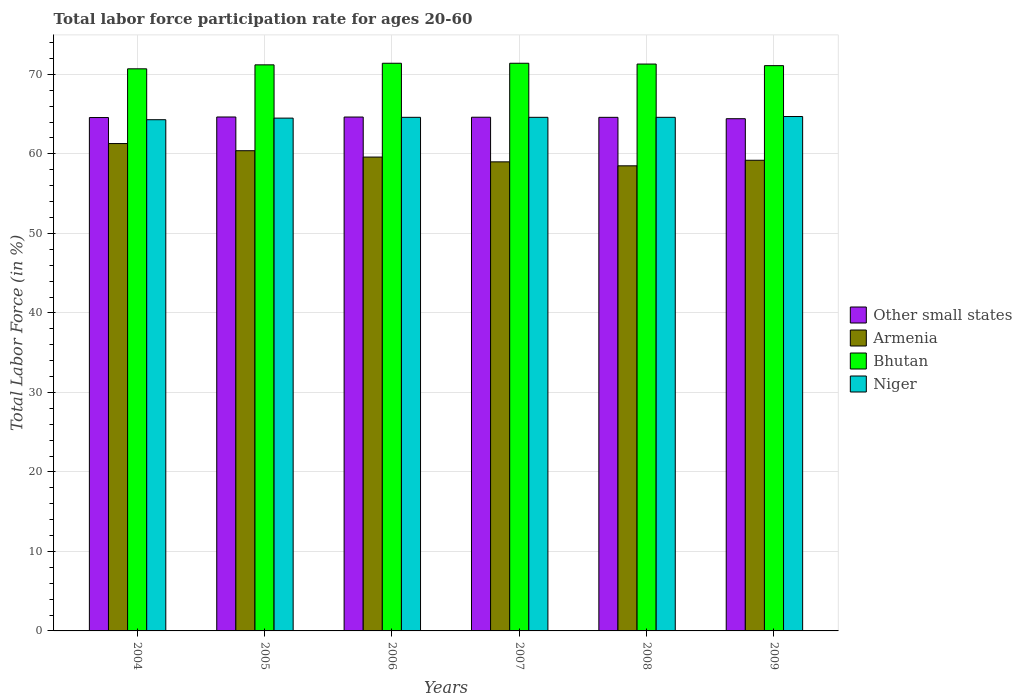How many groups of bars are there?
Make the answer very short. 6. Are the number of bars per tick equal to the number of legend labels?
Provide a succinct answer. Yes. How many bars are there on the 2nd tick from the left?
Offer a very short reply. 4. How many bars are there on the 4th tick from the right?
Offer a very short reply. 4. What is the labor force participation rate in Armenia in 2006?
Your answer should be compact. 59.6. Across all years, what is the maximum labor force participation rate in Niger?
Make the answer very short. 64.7. Across all years, what is the minimum labor force participation rate in Armenia?
Your response must be concise. 58.5. In which year was the labor force participation rate in Armenia maximum?
Offer a very short reply. 2004. In which year was the labor force participation rate in Bhutan minimum?
Ensure brevity in your answer.  2004. What is the total labor force participation rate in Niger in the graph?
Ensure brevity in your answer.  387.3. What is the difference between the labor force participation rate in Niger in 2004 and that in 2007?
Keep it short and to the point. -0.3. What is the difference between the labor force participation rate in Armenia in 2007 and the labor force participation rate in Other small states in 2006?
Your answer should be very brief. -5.64. What is the average labor force participation rate in Armenia per year?
Ensure brevity in your answer.  59.67. In the year 2005, what is the difference between the labor force participation rate in Armenia and labor force participation rate in Niger?
Offer a very short reply. -4.1. In how many years, is the labor force participation rate in Other small states greater than 68 %?
Offer a terse response. 0. What is the ratio of the labor force participation rate in Bhutan in 2004 to that in 2009?
Your response must be concise. 0.99. Is the labor force participation rate in Armenia in 2007 less than that in 2008?
Make the answer very short. No. What is the difference between the highest and the second highest labor force participation rate in Niger?
Provide a succinct answer. 0.1. What is the difference between the highest and the lowest labor force participation rate in Armenia?
Provide a succinct answer. 2.8. In how many years, is the labor force participation rate in Other small states greater than the average labor force participation rate in Other small states taken over all years?
Provide a short and direct response. 4. Is it the case that in every year, the sum of the labor force participation rate in Niger and labor force participation rate in Bhutan is greater than the sum of labor force participation rate in Armenia and labor force participation rate in Other small states?
Offer a very short reply. Yes. What does the 3rd bar from the left in 2009 represents?
Offer a very short reply. Bhutan. What does the 2nd bar from the right in 2007 represents?
Your response must be concise. Bhutan. How many bars are there?
Offer a terse response. 24. Are all the bars in the graph horizontal?
Provide a short and direct response. No. Are the values on the major ticks of Y-axis written in scientific E-notation?
Make the answer very short. No. Does the graph contain grids?
Make the answer very short. Yes. How many legend labels are there?
Provide a short and direct response. 4. What is the title of the graph?
Your response must be concise. Total labor force participation rate for ages 20-60. Does "Malawi" appear as one of the legend labels in the graph?
Make the answer very short. No. What is the label or title of the Y-axis?
Your answer should be compact. Total Labor Force (in %). What is the Total Labor Force (in %) of Other small states in 2004?
Provide a succinct answer. 64.57. What is the Total Labor Force (in %) in Armenia in 2004?
Make the answer very short. 61.3. What is the Total Labor Force (in %) of Bhutan in 2004?
Ensure brevity in your answer.  70.7. What is the Total Labor Force (in %) of Niger in 2004?
Your response must be concise. 64.3. What is the Total Labor Force (in %) in Other small states in 2005?
Offer a very short reply. 64.64. What is the Total Labor Force (in %) in Armenia in 2005?
Keep it short and to the point. 60.4. What is the Total Labor Force (in %) of Bhutan in 2005?
Make the answer very short. 71.2. What is the Total Labor Force (in %) in Niger in 2005?
Provide a succinct answer. 64.5. What is the Total Labor Force (in %) in Other small states in 2006?
Keep it short and to the point. 64.64. What is the Total Labor Force (in %) of Armenia in 2006?
Ensure brevity in your answer.  59.6. What is the Total Labor Force (in %) in Bhutan in 2006?
Your response must be concise. 71.4. What is the Total Labor Force (in %) of Niger in 2006?
Your answer should be very brief. 64.6. What is the Total Labor Force (in %) of Other small states in 2007?
Ensure brevity in your answer.  64.61. What is the Total Labor Force (in %) in Bhutan in 2007?
Offer a terse response. 71.4. What is the Total Labor Force (in %) of Niger in 2007?
Provide a short and direct response. 64.6. What is the Total Labor Force (in %) in Other small states in 2008?
Your answer should be compact. 64.6. What is the Total Labor Force (in %) of Armenia in 2008?
Offer a terse response. 58.5. What is the Total Labor Force (in %) of Bhutan in 2008?
Provide a succinct answer. 71.3. What is the Total Labor Force (in %) in Niger in 2008?
Make the answer very short. 64.6. What is the Total Labor Force (in %) of Other small states in 2009?
Your response must be concise. 64.42. What is the Total Labor Force (in %) in Armenia in 2009?
Make the answer very short. 59.2. What is the Total Labor Force (in %) in Bhutan in 2009?
Your answer should be very brief. 71.1. What is the Total Labor Force (in %) in Niger in 2009?
Your response must be concise. 64.7. Across all years, what is the maximum Total Labor Force (in %) of Other small states?
Offer a very short reply. 64.64. Across all years, what is the maximum Total Labor Force (in %) in Armenia?
Your answer should be very brief. 61.3. Across all years, what is the maximum Total Labor Force (in %) in Bhutan?
Provide a short and direct response. 71.4. Across all years, what is the maximum Total Labor Force (in %) of Niger?
Ensure brevity in your answer.  64.7. Across all years, what is the minimum Total Labor Force (in %) in Other small states?
Your answer should be very brief. 64.42. Across all years, what is the minimum Total Labor Force (in %) in Armenia?
Your answer should be compact. 58.5. Across all years, what is the minimum Total Labor Force (in %) in Bhutan?
Give a very brief answer. 70.7. Across all years, what is the minimum Total Labor Force (in %) of Niger?
Your response must be concise. 64.3. What is the total Total Labor Force (in %) of Other small states in the graph?
Provide a succinct answer. 387.48. What is the total Total Labor Force (in %) of Armenia in the graph?
Give a very brief answer. 358. What is the total Total Labor Force (in %) in Bhutan in the graph?
Offer a terse response. 427.1. What is the total Total Labor Force (in %) in Niger in the graph?
Your answer should be very brief. 387.3. What is the difference between the Total Labor Force (in %) in Other small states in 2004 and that in 2005?
Your answer should be compact. -0.07. What is the difference between the Total Labor Force (in %) of Armenia in 2004 and that in 2005?
Give a very brief answer. 0.9. What is the difference between the Total Labor Force (in %) in Bhutan in 2004 and that in 2005?
Your answer should be compact. -0.5. What is the difference between the Total Labor Force (in %) of Niger in 2004 and that in 2005?
Give a very brief answer. -0.2. What is the difference between the Total Labor Force (in %) of Other small states in 2004 and that in 2006?
Your answer should be compact. -0.06. What is the difference between the Total Labor Force (in %) in Armenia in 2004 and that in 2006?
Provide a short and direct response. 1.7. What is the difference between the Total Labor Force (in %) in Niger in 2004 and that in 2006?
Provide a succinct answer. -0.3. What is the difference between the Total Labor Force (in %) in Other small states in 2004 and that in 2007?
Provide a short and direct response. -0.04. What is the difference between the Total Labor Force (in %) in Armenia in 2004 and that in 2007?
Offer a terse response. 2.3. What is the difference between the Total Labor Force (in %) in Bhutan in 2004 and that in 2007?
Your response must be concise. -0.7. What is the difference between the Total Labor Force (in %) of Niger in 2004 and that in 2007?
Make the answer very short. -0.3. What is the difference between the Total Labor Force (in %) of Other small states in 2004 and that in 2008?
Give a very brief answer. -0.02. What is the difference between the Total Labor Force (in %) in Armenia in 2004 and that in 2008?
Your answer should be compact. 2.8. What is the difference between the Total Labor Force (in %) in Bhutan in 2004 and that in 2008?
Give a very brief answer. -0.6. What is the difference between the Total Labor Force (in %) in Other small states in 2004 and that in 2009?
Your response must be concise. 0.15. What is the difference between the Total Labor Force (in %) in Other small states in 2005 and that in 2006?
Provide a succinct answer. 0.01. What is the difference between the Total Labor Force (in %) in Armenia in 2005 and that in 2006?
Offer a very short reply. 0.8. What is the difference between the Total Labor Force (in %) of Bhutan in 2005 and that in 2006?
Make the answer very short. -0.2. What is the difference between the Total Labor Force (in %) of Niger in 2005 and that in 2006?
Offer a terse response. -0.1. What is the difference between the Total Labor Force (in %) of Other small states in 2005 and that in 2007?
Keep it short and to the point. 0.03. What is the difference between the Total Labor Force (in %) of Armenia in 2005 and that in 2007?
Provide a short and direct response. 1.4. What is the difference between the Total Labor Force (in %) in Bhutan in 2005 and that in 2007?
Your response must be concise. -0.2. What is the difference between the Total Labor Force (in %) of Other small states in 2005 and that in 2008?
Give a very brief answer. 0.04. What is the difference between the Total Labor Force (in %) of Armenia in 2005 and that in 2008?
Provide a short and direct response. 1.9. What is the difference between the Total Labor Force (in %) of Other small states in 2005 and that in 2009?
Offer a very short reply. 0.22. What is the difference between the Total Labor Force (in %) of Armenia in 2005 and that in 2009?
Make the answer very short. 1.2. What is the difference between the Total Labor Force (in %) of Other small states in 2006 and that in 2007?
Your response must be concise. 0.02. What is the difference between the Total Labor Force (in %) in Armenia in 2006 and that in 2007?
Your answer should be compact. 0.6. What is the difference between the Total Labor Force (in %) in Bhutan in 2006 and that in 2007?
Make the answer very short. 0. What is the difference between the Total Labor Force (in %) of Other small states in 2006 and that in 2008?
Provide a succinct answer. 0.04. What is the difference between the Total Labor Force (in %) of Armenia in 2006 and that in 2008?
Provide a succinct answer. 1.1. What is the difference between the Total Labor Force (in %) of Niger in 2006 and that in 2008?
Offer a very short reply. 0. What is the difference between the Total Labor Force (in %) in Other small states in 2006 and that in 2009?
Make the answer very short. 0.21. What is the difference between the Total Labor Force (in %) in Bhutan in 2006 and that in 2009?
Provide a succinct answer. 0.3. What is the difference between the Total Labor Force (in %) in Other small states in 2007 and that in 2008?
Provide a short and direct response. 0.01. What is the difference between the Total Labor Force (in %) in Armenia in 2007 and that in 2008?
Your answer should be compact. 0.5. What is the difference between the Total Labor Force (in %) in Other small states in 2007 and that in 2009?
Provide a short and direct response. 0.19. What is the difference between the Total Labor Force (in %) of Bhutan in 2007 and that in 2009?
Provide a succinct answer. 0.3. What is the difference between the Total Labor Force (in %) of Niger in 2007 and that in 2009?
Ensure brevity in your answer.  -0.1. What is the difference between the Total Labor Force (in %) in Other small states in 2008 and that in 2009?
Provide a succinct answer. 0.17. What is the difference between the Total Labor Force (in %) in Bhutan in 2008 and that in 2009?
Offer a terse response. 0.2. What is the difference between the Total Labor Force (in %) in Niger in 2008 and that in 2009?
Your answer should be very brief. -0.1. What is the difference between the Total Labor Force (in %) of Other small states in 2004 and the Total Labor Force (in %) of Armenia in 2005?
Give a very brief answer. 4.17. What is the difference between the Total Labor Force (in %) in Other small states in 2004 and the Total Labor Force (in %) in Bhutan in 2005?
Offer a very short reply. -6.63. What is the difference between the Total Labor Force (in %) in Other small states in 2004 and the Total Labor Force (in %) in Niger in 2005?
Your response must be concise. 0.07. What is the difference between the Total Labor Force (in %) of Armenia in 2004 and the Total Labor Force (in %) of Bhutan in 2005?
Provide a short and direct response. -9.9. What is the difference between the Total Labor Force (in %) of Armenia in 2004 and the Total Labor Force (in %) of Niger in 2005?
Your answer should be very brief. -3.2. What is the difference between the Total Labor Force (in %) in Bhutan in 2004 and the Total Labor Force (in %) in Niger in 2005?
Ensure brevity in your answer.  6.2. What is the difference between the Total Labor Force (in %) of Other small states in 2004 and the Total Labor Force (in %) of Armenia in 2006?
Provide a succinct answer. 4.97. What is the difference between the Total Labor Force (in %) in Other small states in 2004 and the Total Labor Force (in %) in Bhutan in 2006?
Your response must be concise. -6.83. What is the difference between the Total Labor Force (in %) in Other small states in 2004 and the Total Labor Force (in %) in Niger in 2006?
Your answer should be very brief. -0.03. What is the difference between the Total Labor Force (in %) in Armenia in 2004 and the Total Labor Force (in %) in Bhutan in 2006?
Offer a very short reply. -10.1. What is the difference between the Total Labor Force (in %) of Bhutan in 2004 and the Total Labor Force (in %) of Niger in 2006?
Keep it short and to the point. 6.1. What is the difference between the Total Labor Force (in %) in Other small states in 2004 and the Total Labor Force (in %) in Armenia in 2007?
Offer a terse response. 5.57. What is the difference between the Total Labor Force (in %) in Other small states in 2004 and the Total Labor Force (in %) in Bhutan in 2007?
Offer a very short reply. -6.83. What is the difference between the Total Labor Force (in %) of Other small states in 2004 and the Total Labor Force (in %) of Niger in 2007?
Provide a short and direct response. -0.03. What is the difference between the Total Labor Force (in %) of Armenia in 2004 and the Total Labor Force (in %) of Bhutan in 2007?
Offer a very short reply. -10.1. What is the difference between the Total Labor Force (in %) of Bhutan in 2004 and the Total Labor Force (in %) of Niger in 2007?
Your response must be concise. 6.1. What is the difference between the Total Labor Force (in %) of Other small states in 2004 and the Total Labor Force (in %) of Armenia in 2008?
Your answer should be compact. 6.07. What is the difference between the Total Labor Force (in %) of Other small states in 2004 and the Total Labor Force (in %) of Bhutan in 2008?
Offer a terse response. -6.73. What is the difference between the Total Labor Force (in %) in Other small states in 2004 and the Total Labor Force (in %) in Niger in 2008?
Offer a very short reply. -0.03. What is the difference between the Total Labor Force (in %) in Armenia in 2004 and the Total Labor Force (in %) in Bhutan in 2008?
Your answer should be compact. -10. What is the difference between the Total Labor Force (in %) of Armenia in 2004 and the Total Labor Force (in %) of Niger in 2008?
Give a very brief answer. -3.3. What is the difference between the Total Labor Force (in %) in Bhutan in 2004 and the Total Labor Force (in %) in Niger in 2008?
Give a very brief answer. 6.1. What is the difference between the Total Labor Force (in %) in Other small states in 2004 and the Total Labor Force (in %) in Armenia in 2009?
Give a very brief answer. 5.37. What is the difference between the Total Labor Force (in %) of Other small states in 2004 and the Total Labor Force (in %) of Bhutan in 2009?
Your answer should be compact. -6.53. What is the difference between the Total Labor Force (in %) of Other small states in 2004 and the Total Labor Force (in %) of Niger in 2009?
Your answer should be compact. -0.13. What is the difference between the Total Labor Force (in %) in Armenia in 2004 and the Total Labor Force (in %) in Bhutan in 2009?
Provide a succinct answer. -9.8. What is the difference between the Total Labor Force (in %) in Bhutan in 2004 and the Total Labor Force (in %) in Niger in 2009?
Ensure brevity in your answer.  6. What is the difference between the Total Labor Force (in %) of Other small states in 2005 and the Total Labor Force (in %) of Armenia in 2006?
Keep it short and to the point. 5.04. What is the difference between the Total Labor Force (in %) in Other small states in 2005 and the Total Labor Force (in %) in Bhutan in 2006?
Give a very brief answer. -6.76. What is the difference between the Total Labor Force (in %) of Other small states in 2005 and the Total Labor Force (in %) of Niger in 2006?
Your answer should be compact. 0.04. What is the difference between the Total Labor Force (in %) of Bhutan in 2005 and the Total Labor Force (in %) of Niger in 2006?
Offer a very short reply. 6.6. What is the difference between the Total Labor Force (in %) in Other small states in 2005 and the Total Labor Force (in %) in Armenia in 2007?
Your answer should be compact. 5.64. What is the difference between the Total Labor Force (in %) in Other small states in 2005 and the Total Labor Force (in %) in Bhutan in 2007?
Provide a succinct answer. -6.76. What is the difference between the Total Labor Force (in %) of Other small states in 2005 and the Total Labor Force (in %) of Niger in 2007?
Offer a terse response. 0.04. What is the difference between the Total Labor Force (in %) in Armenia in 2005 and the Total Labor Force (in %) in Bhutan in 2007?
Offer a terse response. -11. What is the difference between the Total Labor Force (in %) in Armenia in 2005 and the Total Labor Force (in %) in Niger in 2007?
Your answer should be very brief. -4.2. What is the difference between the Total Labor Force (in %) in Other small states in 2005 and the Total Labor Force (in %) in Armenia in 2008?
Offer a very short reply. 6.14. What is the difference between the Total Labor Force (in %) in Other small states in 2005 and the Total Labor Force (in %) in Bhutan in 2008?
Make the answer very short. -6.66. What is the difference between the Total Labor Force (in %) of Other small states in 2005 and the Total Labor Force (in %) of Niger in 2008?
Keep it short and to the point. 0.04. What is the difference between the Total Labor Force (in %) of Bhutan in 2005 and the Total Labor Force (in %) of Niger in 2008?
Ensure brevity in your answer.  6.6. What is the difference between the Total Labor Force (in %) in Other small states in 2005 and the Total Labor Force (in %) in Armenia in 2009?
Offer a terse response. 5.44. What is the difference between the Total Labor Force (in %) of Other small states in 2005 and the Total Labor Force (in %) of Bhutan in 2009?
Your response must be concise. -6.46. What is the difference between the Total Labor Force (in %) of Other small states in 2005 and the Total Labor Force (in %) of Niger in 2009?
Provide a succinct answer. -0.06. What is the difference between the Total Labor Force (in %) in Armenia in 2005 and the Total Labor Force (in %) in Niger in 2009?
Offer a terse response. -4.3. What is the difference between the Total Labor Force (in %) in Bhutan in 2005 and the Total Labor Force (in %) in Niger in 2009?
Provide a succinct answer. 6.5. What is the difference between the Total Labor Force (in %) in Other small states in 2006 and the Total Labor Force (in %) in Armenia in 2007?
Keep it short and to the point. 5.64. What is the difference between the Total Labor Force (in %) of Other small states in 2006 and the Total Labor Force (in %) of Bhutan in 2007?
Your answer should be very brief. -6.76. What is the difference between the Total Labor Force (in %) in Other small states in 2006 and the Total Labor Force (in %) in Niger in 2007?
Provide a succinct answer. 0.04. What is the difference between the Total Labor Force (in %) in Armenia in 2006 and the Total Labor Force (in %) in Bhutan in 2007?
Offer a very short reply. -11.8. What is the difference between the Total Labor Force (in %) in Armenia in 2006 and the Total Labor Force (in %) in Niger in 2007?
Offer a terse response. -5. What is the difference between the Total Labor Force (in %) of Other small states in 2006 and the Total Labor Force (in %) of Armenia in 2008?
Provide a succinct answer. 6.14. What is the difference between the Total Labor Force (in %) of Other small states in 2006 and the Total Labor Force (in %) of Bhutan in 2008?
Ensure brevity in your answer.  -6.66. What is the difference between the Total Labor Force (in %) in Other small states in 2006 and the Total Labor Force (in %) in Niger in 2008?
Your response must be concise. 0.04. What is the difference between the Total Labor Force (in %) of Armenia in 2006 and the Total Labor Force (in %) of Bhutan in 2008?
Your response must be concise. -11.7. What is the difference between the Total Labor Force (in %) in Armenia in 2006 and the Total Labor Force (in %) in Niger in 2008?
Provide a succinct answer. -5. What is the difference between the Total Labor Force (in %) in Other small states in 2006 and the Total Labor Force (in %) in Armenia in 2009?
Offer a terse response. 5.44. What is the difference between the Total Labor Force (in %) in Other small states in 2006 and the Total Labor Force (in %) in Bhutan in 2009?
Your response must be concise. -6.46. What is the difference between the Total Labor Force (in %) of Other small states in 2006 and the Total Labor Force (in %) of Niger in 2009?
Offer a terse response. -0.06. What is the difference between the Total Labor Force (in %) in Armenia in 2006 and the Total Labor Force (in %) in Bhutan in 2009?
Your response must be concise. -11.5. What is the difference between the Total Labor Force (in %) of Armenia in 2006 and the Total Labor Force (in %) of Niger in 2009?
Offer a terse response. -5.1. What is the difference between the Total Labor Force (in %) of Bhutan in 2006 and the Total Labor Force (in %) of Niger in 2009?
Make the answer very short. 6.7. What is the difference between the Total Labor Force (in %) of Other small states in 2007 and the Total Labor Force (in %) of Armenia in 2008?
Ensure brevity in your answer.  6.11. What is the difference between the Total Labor Force (in %) in Other small states in 2007 and the Total Labor Force (in %) in Bhutan in 2008?
Make the answer very short. -6.69. What is the difference between the Total Labor Force (in %) in Other small states in 2007 and the Total Labor Force (in %) in Niger in 2008?
Provide a short and direct response. 0.01. What is the difference between the Total Labor Force (in %) in Armenia in 2007 and the Total Labor Force (in %) in Bhutan in 2008?
Provide a succinct answer. -12.3. What is the difference between the Total Labor Force (in %) in Other small states in 2007 and the Total Labor Force (in %) in Armenia in 2009?
Your response must be concise. 5.41. What is the difference between the Total Labor Force (in %) in Other small states in 2007 and the Total Labor Force (in %) in Bhutan in 2009?
Provide a succinct answer. -6.49. What is the difference between the Total Labor Force (in %) of Other small states in 2007 and the Total Labor Force (in %) of Niger in 2009?
Your answer should be compact. -0.09. What is the difference between the Total Labor Force (in %) of Armenia in 2007 and the Total Labor Force (in %) of Niger in 2009?
Your response must be concise. -5.7. What is the difference between the Total Labor Force (in %) of Other small states in 2008 and the Total Labor Force (in %) of Armenia in 2009?
Your answer should be very brief. 5.4. What is the difference between the Total Labor Force (in %) of Other small states in 2008 and the Total Labor Force (in %) of Bhutan in 2009?
Offer a very short reply. -6.5. What is the difference between the Total Labor Force (in %) in Other small states in 2008 and the Total Labor Force (in %) in Niger in 2009?
Keep it short and to the point. -0.1. What is the difference between the Total Labor Force (in %) of Armenia in 2008 and the Total Labor Force (in %) of Bhutan in 2009?
Your answer should be very brief. -12.6. What is the difference between the Total Labor Force (in %) in Armenia in 2008 and the Total Labor Force (in %) in Niger in 2009?
Offer a terse response. -6.2. What is the average Total Labor Force (in %) of Other small states per year?
Give a very brief answer. 64.58. What is the average Total Labor Force (in %) of Armenia per year?
Ensure brevity in your answer.  59.67. What is the average Total Labor Force (in %) of Bhutan per year?
Make the answer very short. 71.18. What is the average Total Labor Force (in %) of Niger per year?
Make the answer very short. 64.55. In the year 2004, what is the difference between the Total Labor Force (in %) in Other small states and Total Labor Force (in %) in Armenia?
Give a very brief answer. 3.27. In the year 2004, what is the difference between the Total Labor Force (in %) in Other small states and Total Labor Force (in %) in Bhutan?
Make the answer very short. -6.13. In the year 2004, what is the difference between the Total Labor Force (in %) in Other small states and Total Labor Force (in %) in Niger?
Provide a succinct answer. 0.27. In the year 2004, what is the difference between the Total Labor Force (in %) of Armenia and Total Labor Force (in %) of Bhutan?
Your answer should be compact. -9.4. In the year 2004, what is the difference between the Total Labor Force (in %) of Armenia and Total Labor Force (in %) of Niger?
Keep it short and to the point. -3. In the year 2005, what is the difference between the Total Labor Force (in %) in Other small states and Total Labor Force (in %) in Armenia?
Provide a short and direct response. 4.24. In the year 2005, what is the difference between the Total Labor Force (in %) in Other small states and Total Labor Force (in %) in Bhutan?
Your answer should be compact. -6.56. In the year 2005, what is the difference between the Total Labor Force (in %) of Other small states and Total Labor Force (in %) of Niger?
Provide a short and direct response. 0.14. In the year 2005, what is the difference between the Total Labor Force (in %) of Armenia and Total Labor Force (in %) of Bhutan?
Make the answer very short. -10.8. In the year 2005, what is the difference between the Total Labor Force (in %) in Bhutan and Total Labor Force (in %) in Niger?
Keep it short and to the point. 6.7. In the year 2006, what is the difference between the Total Labor Force (in %) of Other small states and Total Labor Force (in %) of Armenia?
Ensure brevity in your answer.  5.04. In the year 2006, what is the difference between the Total Labor Force (in %) in Other small states and Total Labor Force (in %) in Bhutan?
Your answer should be very brief. -6.76. In the year 2006, what is the difference between the Total Labor Force (in %) of Other small states and Total Labor Force (in %) of Niger?
Provide a short and direct response. 0.04. In the year 2006, what is the difference between the Total Labor Force (in %) of Armenia and Total Labor Force (in %) of Niger?
Ensure brevity in your answer.  -5. In the year 2007, what is the difference between the Total Labor Force (in %) in Other small states and Total Labor Force (in %) in Armenia?
Ensure brevity in your answer.  5.61. In the year 2007, what is the difference between the Total Labor Force (in %) of Other small states and Total Labor Force (in %) of Bhutan?
Make the answer very short. -6.79. In the year 2007, what is the difference between the Total Labor Force (in %) in Other small states and Total Labor Force (in %) in Niger?
Your answer should be very brief. 0.01. In the year 2007, what is the difference between the Total Labor Force (in %) in Bhutan and Total Labor Force (in %) in Niger?
Offer a terse response. 6.8. In the year 2008, what is the difference between the Total Labor Force (in %) in Other small states and Total Labor Force (in %) in Armenia?
Your answer should be very brief. 6.1. In the year 2008, what is the difference between the Total Labor Force (in %) of Other small states and Total Labor Force (in %) of Bhutan?
Give a very brief answer. -6.7. In the year 2008, what is the difference between the Total Labor Force (in %) of Other small states and Total Labor Force (in %) of Niger?
Ensure brevity in your answer.  -0. In the year 2008, what is the difference between the Total Labor Force (in %) of Armenia and Total Labor Force (in %) of Niger?
Keep it short and to the point. -6.1. In the year 2009, what is the difference between the Total Labor Force (in %) in Other small states and Total Labor Force (in %) in Armenia?
Make the answer very short. 5.22. In the year 2009, what is the difference between the Total Labor Force (in %) of Other small states and Total Labor Force (in %) of Bhutan?
Provide a short and direct response. -6.68. In the year 2009, what is the difference between the Total Labor Force (in %) of Other small states and Total Labor Force (in %) of Niger?
Provide a succinct answer. -0.28. In the year 2009, what is the difference between the Total Labor Force (in %) of Armenia and Total Labor Force (in %) of Bhutan?
Offer a very short reply. -11.9. In the year 2009, what is the difference between the Total Labor Force (in %) of Bhutan and Total Labor Force (in %) of Niger?
Make the answer very short. 6.4. What is the ratio of the Total Labor Force (in %) in Armenia in 2004 to that in 2005?
Your answer should be compact. 1.01. What is the ratio of the Total Labor Force (in %) of Other small states in 2004 to that in 2006?
Give a very brief answer. 1. What is the ratio of the Total Labor Force (in %) in Armenia in 2004 to that in 2006?
Keep it short and to the point. 1.03. What is the ratio of the Total Labor Force (in %) in Bhutan in 2004 to that in 2006?
Offer a very short reply. 0.99. What is the ratio of the Total Labor Force (in %) in Niger in 2004 to that in 2006?
Give a very brief answer. 1. What is the ratio of the Total Labor Force (in %) in Other small states in 2004 to that in 2007?
Give a very brief answer. 1. What is the ratio of the Total Labor Force (in %) of Armenia in 2004 to that in 2007?
Provide a short and direct response. 1.04. What is the ratio of the Total Labor Force (in %) of Bhutan in 2004 to that in 2007?
Offer a very short reply. 0.99. What is the ratio of the Total Labor Force (in %) in Niger in 2004 to that in 2007?
Your answer should be compact. 1. What is the ratio of the Total Labor Force (in %) of Armenia in 2004 to that in 2008?
Your response must be concise. 1.05. What is the ratio of the Total Labor Force (in %) of Bhutan in 2004 to that in 2008?
Give a very brief answer. 0.99. What is the ratio of the Total Labor Force (in %) of Armenia in 2004 to that in 2009?
Your answer should be very brief. 1.04. What is the ratio of the Total Labor Force (in %) of Bhutan in 2004 to that in 2009?
Keep it short and to the point. 0.99. What is the ratio of the Total Labor Force (in %) in Armenia in 2005 to that in 2006?
Keep it short and to the point. 1.01. What is the ratio of the Total Labor Force (in %) in Bhutan in 2005 to that in 2006?
Keep it short and to the point. 1. What is the ratio of the Total Labor Force (in %) in Niger in 2005 to that in 2006?
Offer a very short reply. 1. What is the ratio of the Total Labor Force (in %) of Other small states in 2005 to that in 2007?
Provide a succinct answer. 1. What is the ratio of the Total Labor Force (in %) in Armenia in 2005 to that in 2007?
Your response must be concise. 1.02. What is the ratio of the Total Labor Force (in %) in Bhutan in 2005 to that in 2007?
Provide a short and direct response. 1. What is the ratio of the Total Labor Force (in %) in Armenia in 2005 to that in 2008?
Your answer should be very brief. 1.03. What is the ratio of the Total Labor Force (in %) of Other small states in 2005 to that in 2009?
Offer a very short reply. 1. What is the ratio of the Total Labor Force (in %) in Armenia in 2005 to that in 2009?
Keep it short and to the point. 1.02. What is the ratio of the Total Labor Force (in %) of Niger in 2005 to that in 2009?
Provide a short and direct response. 1. What is the ratio of the Total Labor Force (in %) in Other small states in 2006 to that in 2007?
Provide a short and direct response. 1. What is the ratio of the Total Labor Force (in %) in Armenia in 2006 to that in 2007?
Provide a succinct answer. 1.01. What is the ratio of the Total Labor Force (in %) in Bhutan in 2006 to that in 2007?
Offer a very short reply. 1. What is the ratio of the Total Labor Force (in %) in Other small states in 2006 to that in 2008?
Provide a short and direct response. 1. What is the ratio of the Total Labor Force (in %) of Armenia in 2006 to that in 2008?
Your answer should be very brief. 1.02. What is the ratio of the Total Labor Force (in %) in Armenia in 2006 to that in 2009?
Offer a terse response. 1.01. What is the ratio of the Total Labor Force (in %) in Niger in 2006 to that in 2009?
Your response must be concise. 1. What is the ratio of the Total Labor Force (in %) in Armenia in 2007 to that in 2008?
Your answer should be compact. 1.01. What is the ratio of the Total Labor Force (in %) in Niger in 2007 to that in 2008?
Offer a very short reply. 1. What is the ratio of the Total Labor Force (in %) of Armenia in 2007 to that in 2009?
Offer a very short reply. 1. What is the ratio of the Total Labor Force (in %) of Other small states in 2008 to that in 2009?
Your response must be concise. 1. What is the ratio of the Total Labor Force (in %) of Armenia in 2008 to that in 2009?
Offer a terse response. 0.99. What is the difference between the highest and the second highest Total Labor Force (in %) of Other small states?
Offer a very short reply. 0.01. What is the difference between the highest and the second highest Total Labor Force (in %) in Armenia?
Your answer should be very brief. 0.9. What is the difference between the highest and the lowest Total Labor Force (in %) in Other small states?
Give a very brief answer. 0.22. What is the difference between the highest and the lowest Total Labor Force (in %) of Bhutan?
Provide a short and direct response. 0.7. 